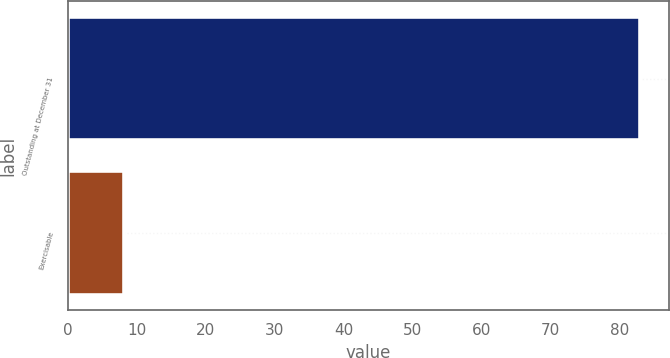Convert chart to OTSL. <chart><loc_0><loc_0><loc_500><loc_500><bar_chart><fcel>Outstanding at December 31<fcel>Exercisable<nl><fcel>83<fcel>8.1<nl></chart> 